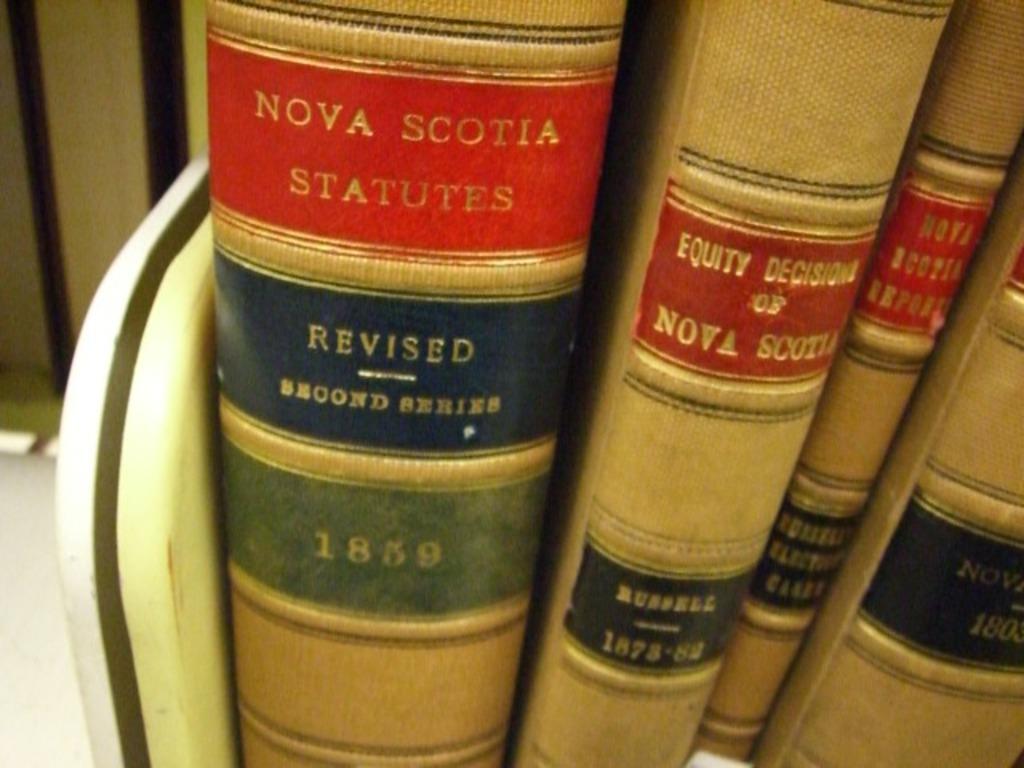What year is this?
Your response must be concise. 1859. What is the name of the first book?
Make the answer very short. Nova scotia statutes. 